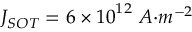<formula> <loc_0><loc_0><loc_500><loc_500>J _ { S O T } = 6 \times { 1 0 } ^ { 1 2 } { \ A { m } ^ { - 2 }</formula> 